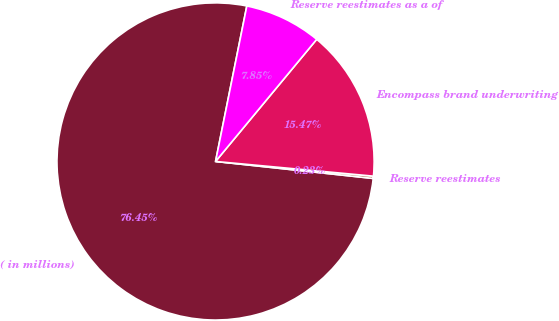<chart> <loc_0><loc_0><loc_500><loc_500><pie_chart><fcel>( in millions)<fcel>Reserve reestimates<fcel>Encompass brand underwriting<fcel>Reserve reestimates as a of<nl><fcel>76.45%<fcel>0.23%<fcel>15.47%<fcel>7.85%<nl></chart> 